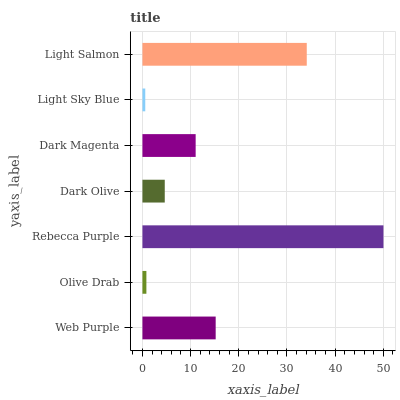Is Light Sky Blue the minimum?
Answer yes or no. Yes. Is Rebecca Purple the maximum?
Answer yes or no. Yes. Is Olive Drab the minimum?
Answer yes or no. No. Is Olive Drab the maximum?
Answer yes or no. No. Is Web Purple greater than Olive Drab?
Answer yes or no. Yes. Is Olive Drab less than Web Purple?
Answer yes or no. Yes. Is Olive Drab greater than Web Purple?
Answer yes or no. No. Is Web Purple less than Olive Drab?
Answer yes or no. No. Is Dark Magenta the high median?
Answer yes or no. Yes. Is Dark Magenta the low median?
Answer yes or no. Yes. Is Rebecca Purple the high median?
Answer yes or no. No. Is Rebecca Purple the low median?
Answer yes or no. No. 